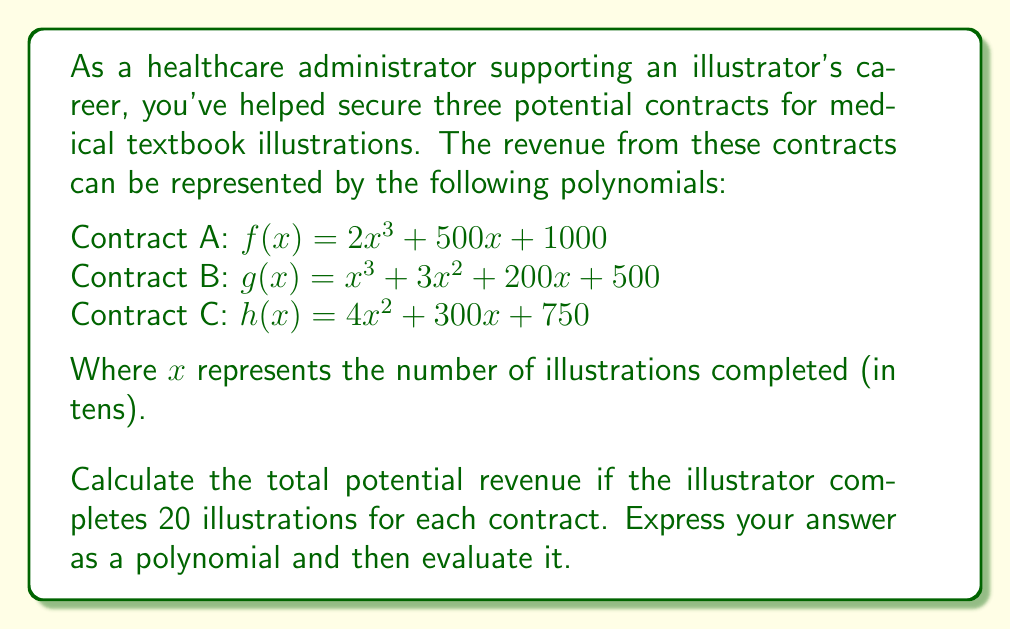Solve this math problem. To solve this problem, we need to follow these steps:

1) First, we need to add the three polynomials to get the total revenue function:

   $T(x) = f(x) + g(x) + h(x)$
   $T(x) = (2x^3 + 500x + 1000) + (x^3 + 3x^2 + 200x + 500) + (4x^2 + 300x + 750)$
   $T(x) = 3x^3 + 7x^2 + 1000x + 2250$

2) Now we have the total revenue function $T(x)$. We need to evaluate this for 20 illustrations.

3) Remember, $x$ represents tens of illustrations. So, 20 illustrations is represented by $x = 2$.

4) Let's substitute $x = 2$ into our total revenue function:

   $T(2) = 3(2^3) + 7(2^2) + 1000(2) + 2250$

5) Now let's calculate each term:

   $3(2^3) = 3(8) = 24$
   $7(2^2) = 7(4) = 28$
   $1000(2) = 2000$
   $2250$ remains as is

6) Adding these together:

   $T(2) = 24 + 28 + 2000 + 2250 = 4302$

Therefore, the total potential revenue for 20 illustrations from each contract is $4302.
Answer: The total potential revenue function is $T(x) = 3x^3 + 7x^2 + 1000x + 2250$, and the total potential revenue for 20 illustrations from each contract is $4302. 